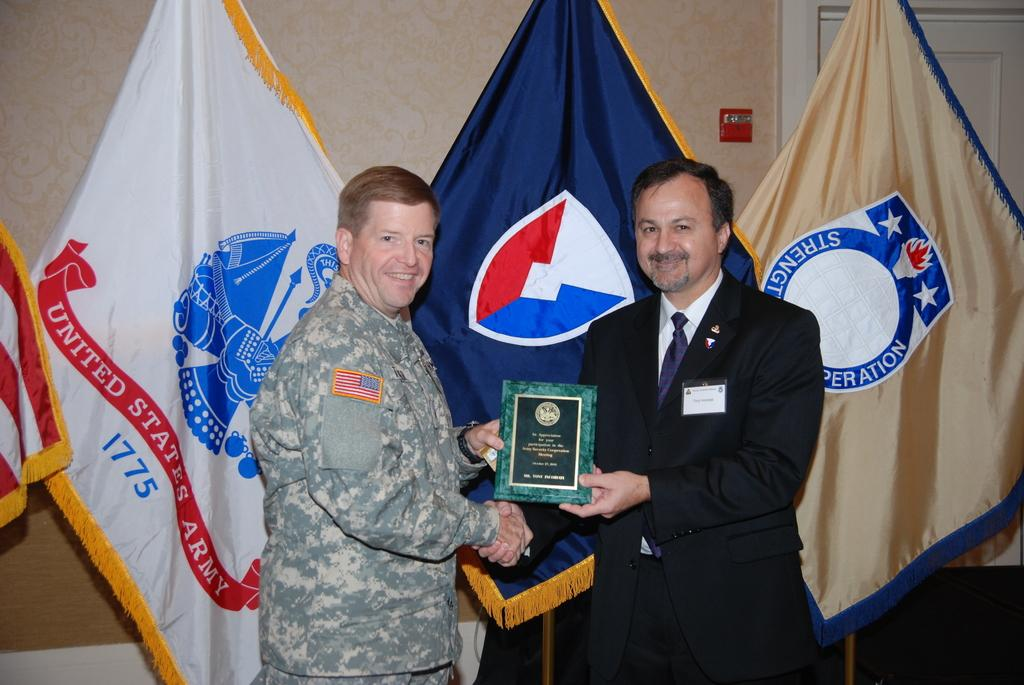<image>
Provide a brief description of the given image. The two men with the award are standing in front of a United States Army flag. 